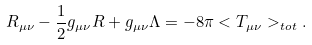<formula> <loc_0><loc_0><loc_500><loc_500>R _ { \mu \nu } - \frac { 1 } { 2 } g _ { \mu \nu } R + g _ { \mu \nu } \Lambda = - 8 \pi < T _ { \mu \nu } > _ { t o t } .</formula> 